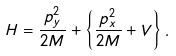<formula> <loc_0><loc_0><loc_500><loc_500>H = \frac { p _ { y } ^ { 2 } } { 2 M } + \left \{ \frac { p _ { x } ^ { 2 } } { 2 M } + V \right \} .</formula> 